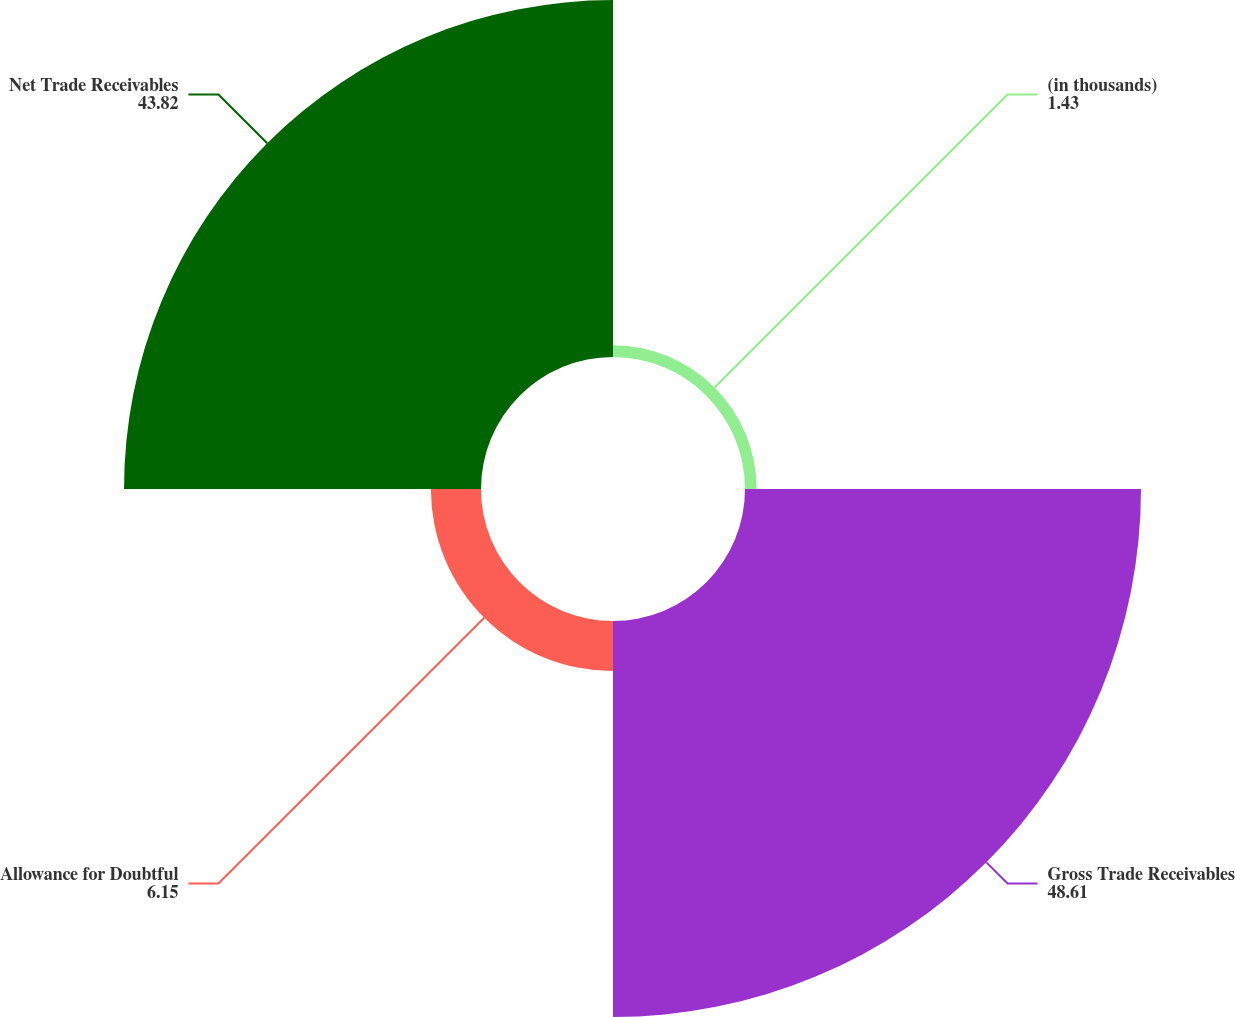<chart> <loc_0><loc_0><loc_500><loc_500><pie_chart><fcel>(in thousands)<fcel>Gross Trade Receivables<fcel>Allowance for Doubtful<fcel>Net Trade Receivables<nl><fcel>1.43%<fcel>48.61%<fcel>6.15%<fcel>43.82%<nl></chart> 